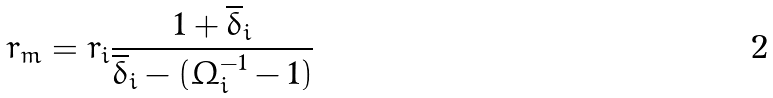<formula> <loc_0><loc_0><loc_500><loc_500>r _ { m } = r _ { i } \frac { 1 + { \overline { \delta } _ { i } } } { { \overline { \delta } _ { i } } - ( \Omega _ { i } ^ { - 1 } - 1 ) }</formula> 